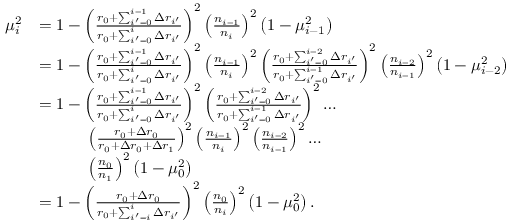<formula> <loc_0><loc_0><loc_500><loc_500>\begin{array} { r l } { \mu _ { i } ^ { 2 } } & { = 1 - \left ( \frac { r _ { 0 } + \sum _ { i ^ { \prime } = 0 } ^ { i - 1 } \Delta r _ { i ^ { \prime } } } { r _ { 0 } + \sum _ { i ^ { \prime } = 0 } ^ { i } \Delta r _ { i ^ { \prime } } } \right ) ^ { 2 } \left ( \frac { n _ { i - 1 } } { n _ { i } } \right ) ^ { 2 } \left ( 1 - \mu _ { i - 1 } ^ { 2 } \right ) } \\ & { = 1 - \left ( \frac { r _ { 0 } + \sum _ { i ^ { \prime } = 0 } ^ { i - 1 } \Delta r _ { i ^ { \prime } } } { r _ { 0 } + \sum _ { i ^ { \prime } = 0 } ^ { i } \Delta r _ { i ^ { \prime } } } \right ) ^ { 2 } \left ( \frac { n _ { i - 1 } } { n _ { i } } \right ) ^ { 2 } \left ( \frac { r _ { 0 } + \sum _ { i ^ { \prime } = 0 } ^ { i - 2 } \Delta r _ { i ^ { \prime } } } { r _ { 0 } + \sum _ { i ^ { \prime } = 0 } ^ { i - 1 } \Delta r _ { i ^ { \prime } } } \right ) ^ { 2 } \left ( \frac { n _ { i - 2 } } { n _ { i - 1 } } \right ) ^ { 2 } \left ( 1 - \mu _ { i - 2 } ^ { 2 } \right ) } \\ & { = 1 - \left ( \frac { r _ { 0 } + \sum _ { i ^ { \prime } = 0 } ^ { i - 1 } \Delta r _ { i ^ { \prime } } } { r _ { 0 } + \sum _ { i ^ { \prime } = 0 } ^ { i } \Delta r _ { i ^ { \prime } } } \right ) ^ { 2 } \left ( \frac { r _ { 0 } + \sum _ { i ^ { \prime } = 0 } ^ { i - 2 } \Delta r _ { i ^ { \prime } } } { r _ { 0 } + \sum _ { i ^ { \prime } = 0 } ^ { i - 1 } \Delta r _ { i ^ { \prime } } } \right ) ^ { 2 } \dots } \\ & { \quad \left ( \frac { r _ { 0 } + \Delta r _ { 0 } } { r _ { 0 } + \Delta r _ { 0 } + \Delta r _ { 1 } } \right ) ^ { 2 } \left ( \frac { n _ { i - 1 } } { n _ { i } } \right ) ^ { 2 } \left ( \frac { n _ { i - 2 } } { n _ { i - 1 } } \right ) ^ { 2 } \dots } \\ & { \quad \left ( \frac { n _ { 0 } } { n _ { 1 } } \right ) ^ { 2 } \left ( 1 - \mu _ { 0 } ^ { 2 } \right ) } \\ & { = 1 - \left ( \frac { r _ { 0 } + \Delta r _ { 0 } } { r _ { 0 } + \sum _ { i ^ { \prime } = i } ^ { i } \Delta r _ { i ^ { \prime } } } \right ) ^ { 2 } \left ( \frac { n _ { 0 } } { n _ { i } } \right ) ^ { 2 } \left ( 1 - \mu _ { 0 } ^ { 2 } \right ) . } \end{array}</formula> 